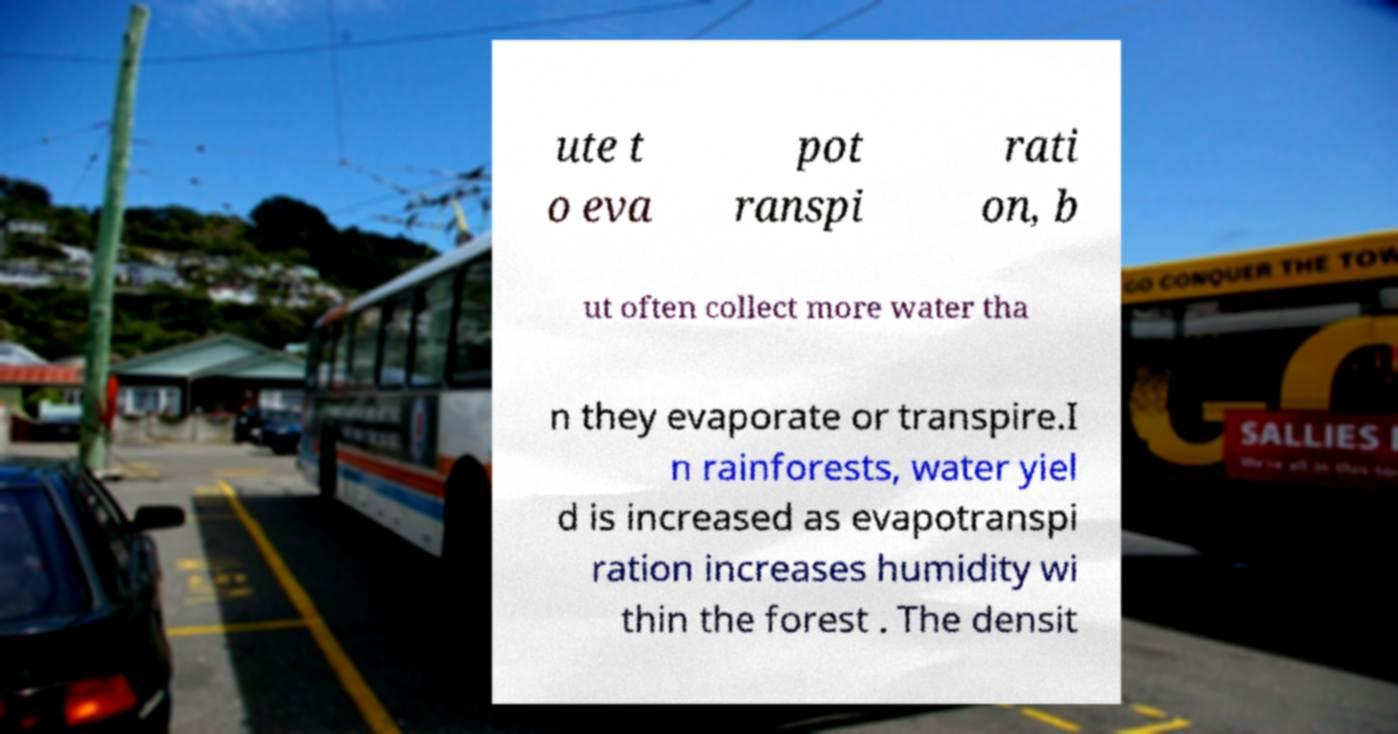Can you read and provide the text displayed in the image?This photo seems to have some interesting text. Can you extract and type it out for me? ute t o eva pot ranspi rati on, b ut often collect more water tha n they evaporate or transpire.I n rainforests, water yiel d is increased as evapotranspi ration increases humidity wi thin the forest . The densit 